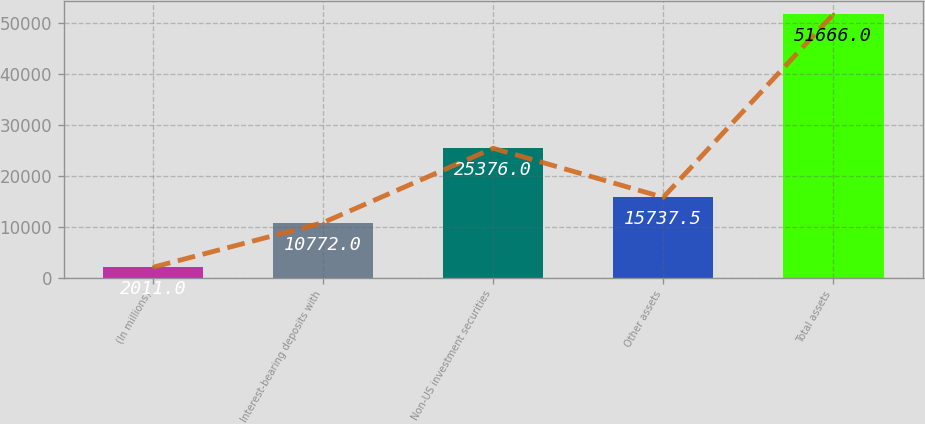Convert chart. <chart><loc_0><loc_0><loc_500><loc_500><bar_chart><fcel>(In millions)<fcel>Interest-bearing deposits with<fcel>Non-US investment securities<fcel>Other assets<fcel>Total assets<nl><fcel>2011<fcel>10772<fcel>25376<fcel>15737.5<fcel>51666<nl></chart> 